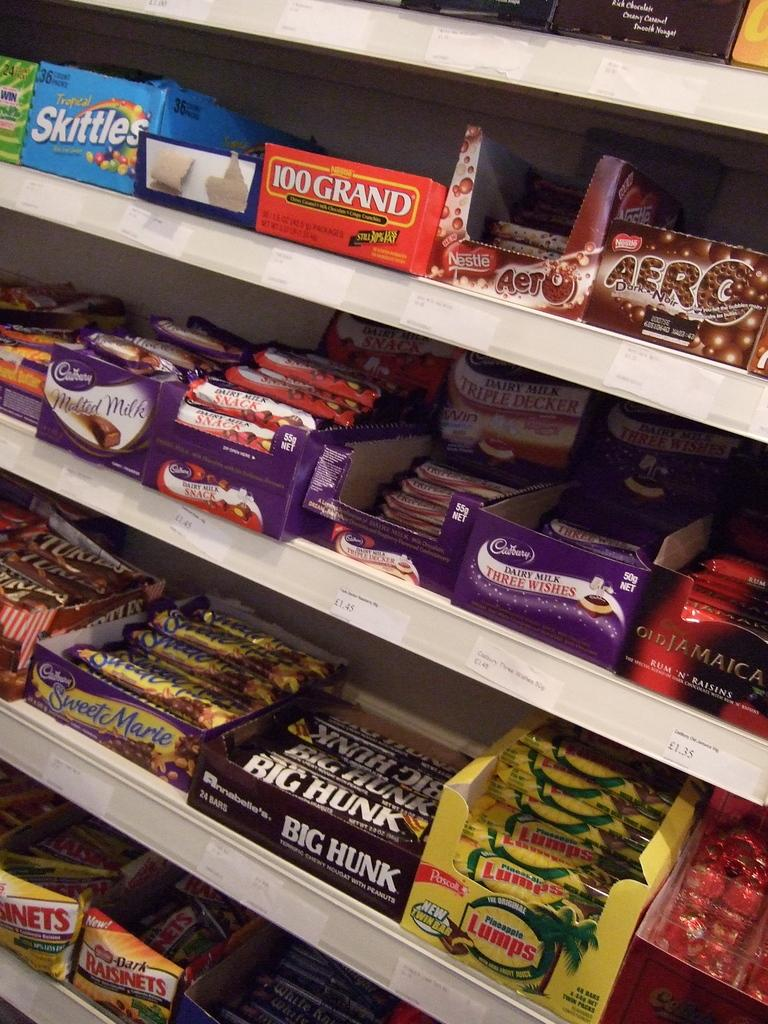Provide a one-sentence caption for the provided image. a candy bar display in a store for candies like Big Hunk and Aero. 